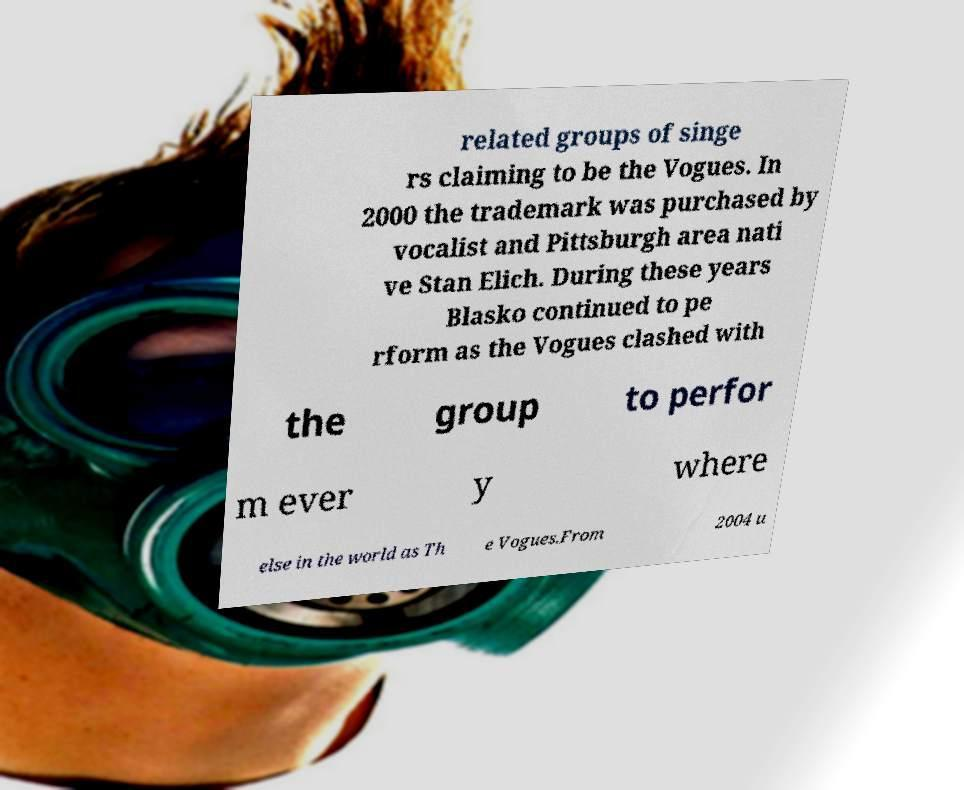Please read and relay the text visible in this image. What does it say? related groups of singe rs claiming to be the Vogues. In 2000 the trademark was purchased by vocalist and Pittsburgh area nati ve Stan Elich. During these years Blasko continued to pe rform as the Vogues clashed with the group to perfor m ever y where else in the world as Th e Vogues.From 2004 u 